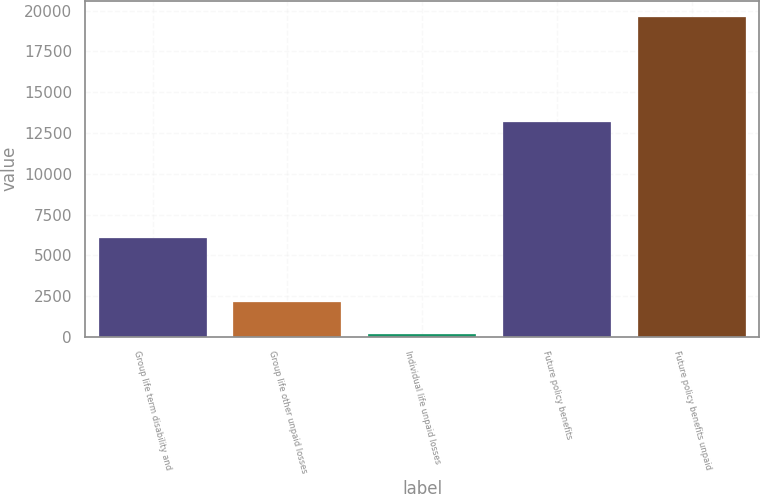Convert chart to OTSL. <chart><loc_0><loc_0><loc_500><loc_500><bar_chart><fcel>Group life term disability and<fcel>Group life other unpaid losses<fcel>Individual life unpaid losses<fcel>Future policy benefits<fcel>Future policy benefits unpaid<nl><fcel>6084<fcel>2117.7<fcel>171<fcel>13180<fcel>19638<nl></chart> 